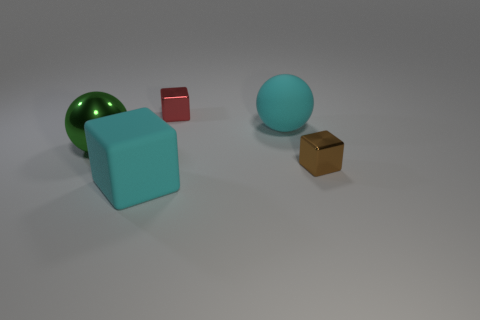Add 2 big things. How many objects exist? 7 Subtract all spheres. How many objects are left? 3 Add 5 metal things. How many metal things exist? 8 Subtract 0 green cylinders. How many objects are left? 5 Subtract all cubes. Subtract all small brown things. How many objects are left? 1 Add 2 cyan matte spheres. How many cyan matte spheres are left? 3 